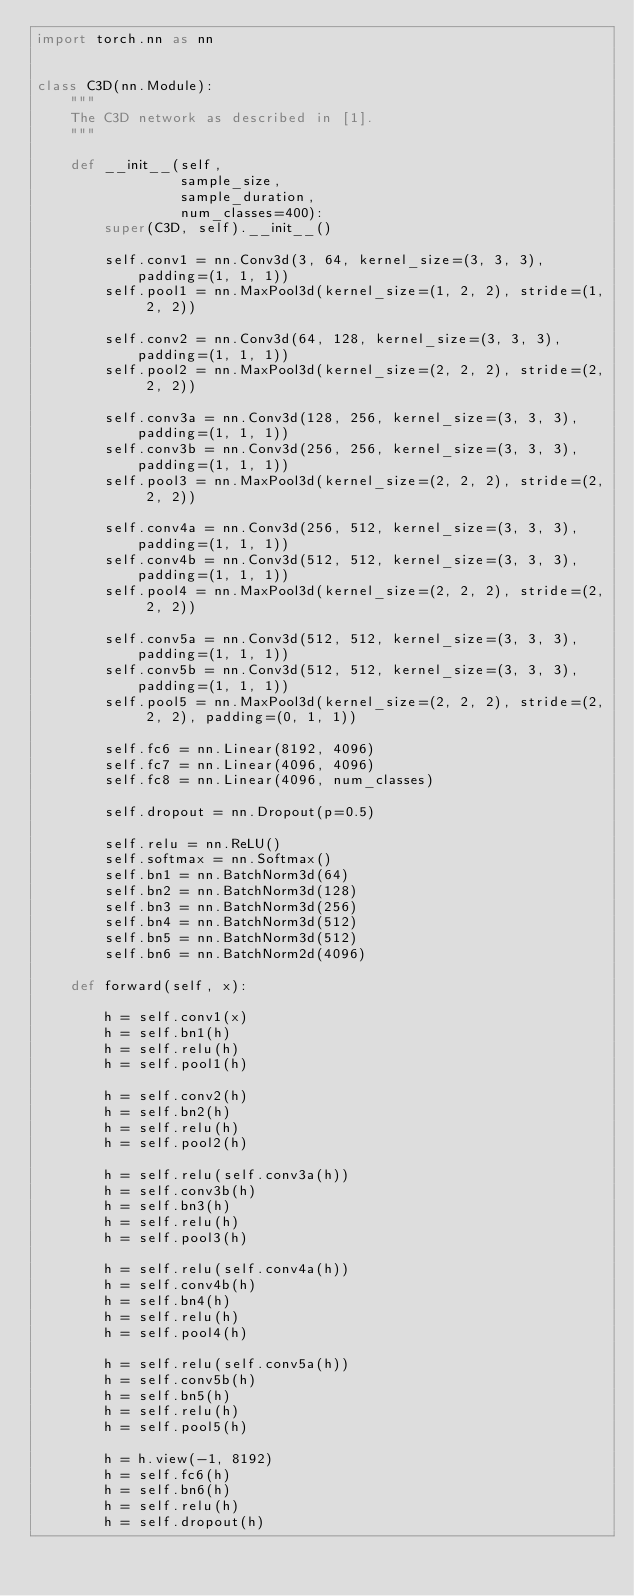<code> <loc_0><loc_0><loc_500><loc_500><_Python_>import torch.nn as nn


class C3D(nn.Module):
    """
    The C3D network as described in [1].
    """

    def __init__(self,
                 sample_size,
                 sample_duration,
                 num_classes=400):
        super(C3D, self).__init__()

        self.conv1 = nn.Conv3d(3, 64, kernel_size=(3, 3, 3), padding=(1, 1, 1))
        self.pool1 = nn.MaxPool3d(kernel_size=(1, 2, 2), stride=(1, 2, 2))

        self.conv2 = nn.Conv3d(64, 128, kernel_size=(3, 3, 3), padding=(1, 1, 1))
        self.pool2 = nn.MaxPool3d(kernel_size=(2, 2, 2), stride=(2, 2, 2))

        self.conv3a = nn.Conv3d(128, 256, kernel_size=(3, 3, 3), padding=(1, 1, 1))
        self.conv3b = nn.Conv3d(256, 256, kernel_size=(3, 3, 3), padding=(1, 1, 1))
        self.pool3 = nn.MaxPool3d(kernel_size=(2, 2, 2), stride=(2, 2, 2))

        self.conv4a = nn.Conv3d(256, 512, kernel_size=(3, 3, 3), padding=(1, 1, 1))
        self.conv4b = nn.Conv3d(512, 512, kernel_size=(3, 3, 3), padding=(1, 1, 1))
        self.pool4 = nn.MaxPool3d(kernel_size=(2, 2, 2), stride=(2, 2, 2))

        self.conv5a = nn.Conv3d(512, 512, kernel_size=(3, 3, 3), padding=(1, 1, 1))
        self.conv5b = nn.Conv3d(512, 512, kernel_size=(3, 3, 3), padding=(1, 1, 1))
        self.pool5 = nn.MaxPool3d(kernel_size=(2, 2, 2), stride=(2, 2, 2), padding=(0, 1, 1))

        self.fc6 = nn.Linear(8192, 4096)
        self.fc7 = nn.Linear(4096, 4096)
        self.fc8 = nn.Linear(4096, num_classes)

        self.dropout = nn.Dropout(p=0.5)

        self.relu = nn.ReLU()
        self.softmax = nn.Softmax()
        self.bn1 = nn.BatchNorm3d(64)
        self.bn2 = nn.BatchNorm3d(128)
        self.bn3 = nn.BatchNorm3d(256)
        self.bn4 = nn.BatchNorm3d(512)
        self.bn5 = nn.BatchNorm3d(512)
        self.bn6 = nn.BatchNorm2d(4096)

    def forward(self, x):

        h = self.conv1(x)
        h = self.bn1(h)
        h = self.relu(h)
        h = self.pool1(h)

        h = self.conv2(h)
        h = self.bn2(h)
        h = self.relu(h)
        h = self.pool2(h)

        h = self.relu(self.conv3a(h))
        h = self.conv3b(h)
        h = self.bn3(h)
        h = self.relu(h)
        h = self.pool3(h)

        h = self.relu(self.conv4a(h))
        h = self.conv4b(h)
        h = self.bn4(h)
        h = self.relu(h)
        h = self.pool4(h)

        h = self.relu(self.conv5a(h))
        h = self.conv5b(h)
        h = self.bn5(h)
        h = self.relu(h)
        h = self.pool5(h)

        h = h.view(-1, 8192)
        h = self.fc6(h)
        h = self.bn6(h)
        h = self.relu(h)
        h = self.dropout(h)</code> 